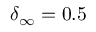<formula> <loc_0><loc_0><loc_500><loc_500>\delta _ { \infty } = 0 . 5</formula> 